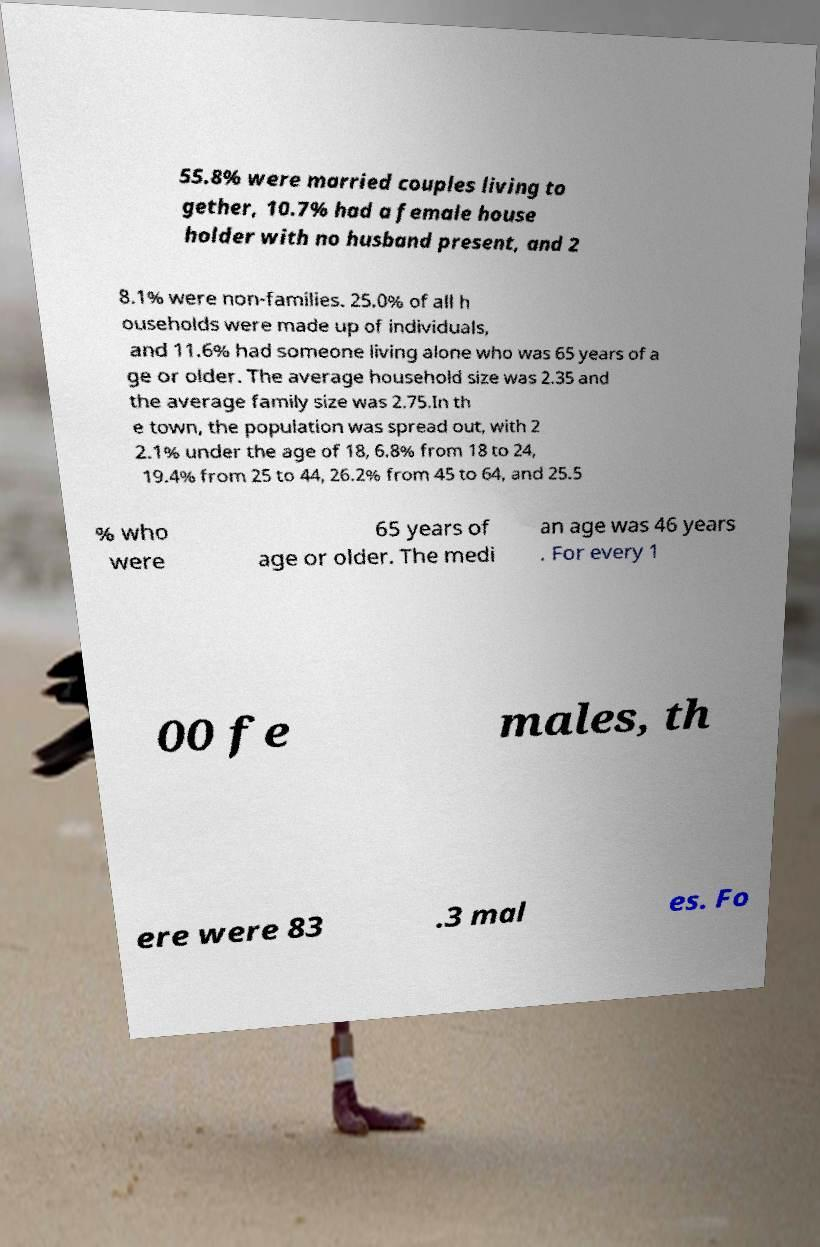Can you accurately transcribe the text from the provided image for me? 55.8% were married couples living to gether, 10.7% had a female house holder with no husband present, and 2 8.1% were non-families. 25.0% of all h ouseholds were made up of individuals, and 11.6% had someone living alone who was 65 years of a ge or older. The average household size was 2.35 and the average family size was 2.75.In th e town, the population was spread out, with 2 2.1% under the age of 18, 6.8% from 18 to 24, 19.4% from 25 to 44, 26.2% from 45 to 64, and 25.5 % who were 65 years of age or older. The medi an age was 46 years . For every 1 00 fe males, th ere were 83 .3 mal es. Fo 